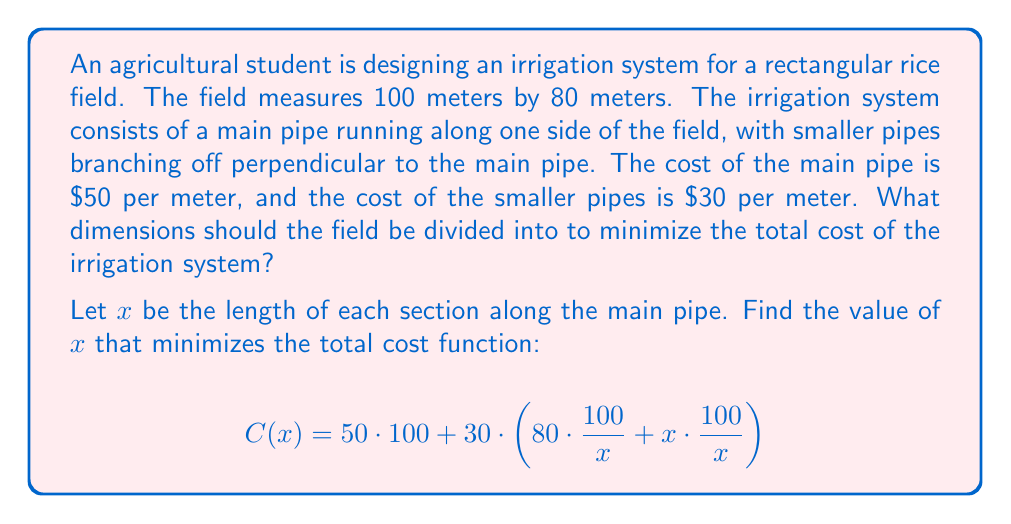Can you solve this math problem? To solve this optimization problem, we'll follow these steps:

1) First, let's simplify the cost function:
   $$C(x) = 5000 + 30 \cdot (80 \cdot \frac{100}{x} + x \cdot \frac{100}{x})$$
   $$C(x) = 5000 + 3000 \cdot (\frac{80}{x} + 1)$$
   $$C(x) = 5000 + \frac{240000}{x} + 3000$$
   $$C(x) = 8000 + \frac{240000}{x}$$

2) To find the minimum, we need to find where the derivative of $C(x)$ equals zero:
   $$C'(x) = -\frac{240000}{x^2}$$

3) Set $C'(x) = 0$:
   $$-\frac{240000}{x^2} = 0$$
   
   This equation has no solution, as $x$ cannot be zero or infinity.

4) However, we can find the minimum by considering the behavior of the function:
   As $x$ approaches 0, $C(x)$ approaches infinity.
   As $x$ approaches infinity, $C(x)$ approaches 8000.
   
   The function must have a minimum somewhere in between.

5) To find this minimum, we can use the second derivative test:
   $$C''(x) = \frac{480000}{x^3}$$
   
   This is always positive for $x > 0$, confirming a minimum.

6) Setting $C'(x) = 0$ and solving for $x$:
   $$-\frac{240000}{x^2} = 0$$
   $$x = \sqrt{240000} = 20\sqrt{600} \approx 489.90$$

7) Therefore, the optimal length for each section is approximately 489.90 meters.

8) However, given that our field is only 100 meters long, this solution is not practical. We need to consider the constraints of our problem.

9) Given the field dimensions, $x$ can only take values that evenly divide 100. The closest valid values are 20 and 25.

10) Let's calculate the cost for these values:
    For $x = 20$: $C(20) = 8000 + \frac{240000}{20} = 20000$
    For $x = 25$: $C(25) = 8000 + \frac{240000}{25} = 17600$

Therefore, the optimal practical solution is to divide the field into 4 sections, each 25 meters long.
Answer: The optimal dimensions to minimize the total cost of the irrigation system are 25 meters by 80 meters. This divides the 100-meter length of the field into 4 equal sections, resulting in a minimum total cost of $17,600. 